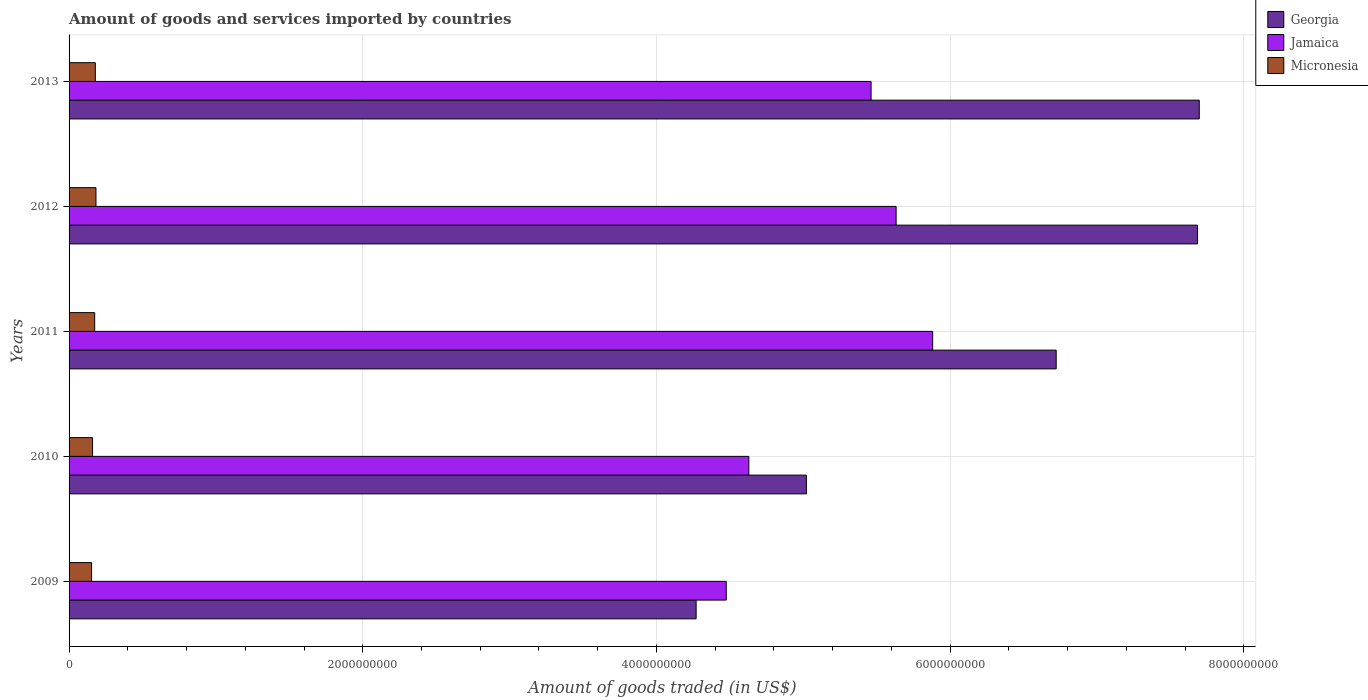How many different coloured bars are there?
Keep it short and to the point. 3. How many bars are there on the 3rd tick from the top?
Your answer should be compact. 3. What is the label of the 5th group of bars from the top?
Ensure brevity in your answer.  2009. What is the total amount of goods and services imported in Georgia in 2011?
Give a very brief answer. 6.72e+09. Across all years, what is the maximum total amount of goods and services imported in Jamaica?
Give a very brief answer. 5.88e+09. Across all years, what is the minimum total amount of goods and services imported in Micronesia?
Give a very brief answer. 1.53e+08. In which year was the total amount of goods and services imported in Georgia minimum?
Provide a short and direct response. 2009. What is the total total amount of goods and services imported in Georgia in the graph?
Your answer should be very brief. 3.14e+1. What is the difference between the total amount of goods and services imported in Micronesia in 2009 and that in 2012?
Offer a very short reply. -2.98e+07. What is the difference between the total amount of goods and services imported in Micronesia in 2013 and the total amount of goods and services imported in Jamaica in 2012?
Give a very brief answer. -5.45e+09. What is the average total amount of goods and services imported in Micronesia per year?
Ensure brevity in your answer.  1.70e+08. In the year 2012, what is the difference between the total amount of goods and services imported in Georgia and total amount of goods and services imported in Micronesia?
Provide a succinct answer. 7.50e+09. In how many years, is the total amount of goods and services imported in Jamaica greater than 7200000000 US$?
Your response must be concise. 0. What is the ratio of the total amount of goods and services imported in Georgia in 2010 to that in 2012?
Make the answer very short. 0.65. Is the difference between the total amount of goods and services imported in Georgia in 2010 and 2012 greater than the difference between the total amount of goods and services imported in Micronesia in 2010 and 2012?
Make the answer very short. No. What is the difference between the highest and the second highest total amount of goods and services imported in Micronesia?
Make the answer very short. 4.27e+06. What is the difference between the highest and the lowest total amount of goods and services imported in Micronesia?
Offer a very short reply. 2.98e+07. In how many years, is the total amount of goods and services imported in Micronesia greater than the average total amount of goods and services imported in Micronesia taken over all years?
Make the answer very short. 3. Is the sum of the total amount of goods and services imported in Micronesia in 2009 and 2011 greater than the maximum total amount of goods and services imported in Jamaica across all years?
Offer a terse response. No. What does the 1st bar from the top in 2009 represents?
Keep it short and to the point. Micronesia. What does the 2nd bar from the bottom in 2012 represents?
Offer a terse response. Jamaica. Is it the case that in every year, the sum of the total amount of goods and services imported in Georgia and total amount of goods and services imported in Jamaica is greater than the total amount of goods and services imported in Micronesia?
Offer a very short reply. Yes. Are all the bars in the graph horizontal?
Ensure brevity in your answer.  Yes. Does the graph contain grids?
Make the answer very short. Yes. How are the legend labels stacked?
Keep it short and to the point. Vertical. What is the title of the graph?
Give a very brief answer. Amount of goods and services imported by countries. Does "Tonga" appear as one of the legend labels in the graph?
Offer a terse response. No. What is the label or title of the X-axis?
Your answer should be very brief. Amount of goods traded (in US$). What is the label or title of the Y-axis?
Provide a short and direct response. Years. What is the Amount of goods traded (in US$) of Georgia in 2009?
Your response must be concise. 4.27e+09. What is the Amount of goods traded (in US$) in Jamaica in 2009?
Your response must be concise. 4.48e+09. What is the Amount of goods traded (in US$) in Micronesia in 2009?
Ensure brevity in your answer.  1.53e+08. What is the Amount of goods traded (in US$) of Georgia in 2010?
Ensure brevity in your answer.  5.02e+09. What is the Amount of goods traded (in US$) of Jamaica in 2010?
Your answer should be compact. 4.63e+09. What is the Amount of goods traded (in US$) of Micronesia in 2010?
Your answer should be very brief. 1.60e+08. What is the Amount of goods traded (in US$) of Georgia in 2011?
Offer a terse response. 6.72e+09. What is the Amount of goods traded (in US$) of Jamaica in 2011?
Provide a short and direct response. 5.88e+09. What is the Amount of goods traded (in US$) of Micronesia in 2011?
Make the answer very short. 1.74e+08. What is the Amount of goods traded (in US$) in Georgia in 2012?
Keep it short and to the point. 7.69e+09. What is the Amount of goods traded (in US$) in Jamaica in 2012?
Your answer should be very brief. 5.63e+09. What is the Amount of goods traded (in US$) in Micronesia in 2012?
Your answer should be very brief. 1.83e+08. What is the Amount of goods traded (in US$) of Georgia in 2013?
Provide a succinct answer. 7.70e+09. What is the Amount of goods traded (in US$) of Jamaica in 2013?
Your response must be concise. 5.46e+09. What is the Amount of goods traded (in US$) of Micronesia in 2013?
Your answer should be compact. 1.79e+08. Across all years, what is the maximum Amount of goods traded (in US$) of Georgia?
Ensure brevity in your answer.  7.70e+09. Across all years, what is the maximum Amount of goods traded (in US$) of Jamaica?
Provide a succinct answer. 5.88e+09. Across all years, what is the maximum Amount of goods traded (in US$) of Micronesia?
Your response must be concise. 1.83e+08. Across all years, what is the minimum Amount of goods traded (in US$) in Georgia?
Keep it short and to the point. 4.27e+09. Across all years, what is the minimum Amount of goods traded (in US$) of Jamaica?
Make the answer very short. 4.48e+09. Across all years, what is the minimum Amount of goods traded (in US$) in Micronesia?
Your answer should be compact. 1.53e+08. What is the total Amount of goods traded (in US$) in Georgia in the graph?
Provide a succinct answer. 3.14e+1. What is the total Amount of goods traded (in US$) in Jamaica in the graph?
Provide a short and direct response. 2.61e+1. What is the total Amount of goods traded (in US$) in Micronesia in the graph?
Your answer should be compact. 8.50e+08. What is the difference between the Amount of goods traded (in US$) in Georgia in 2009 and that in 2010?
Your response must be concise. -7.51e+08. What is the difference between the Amount of goods traded (in US$) in Jamaica in 2009 and that in 2010?
Your answer should be very brief. -1.54e+08. What is the difference between the Amount of goods traded (in US$) in Micronesia in 2009 and that in 2010?
Provide a short and direct response. -6.59e+06. What is the difference between the Amount of goods traded (in US$) in Georgia in 2009 and that in 2011?
Keep it short and to the point. -2.45e+09. What is the difference between the Amount of goods traded (in US$) of Jamaica in 2009 and that in 2011?
Offer a very short reply. -1.41e+09. What is the difference between the Amount of goods traded (in US$) of Micronesia in 2009 and that in 2011?
Give a very brief answer. -2.10e+07. What is the difference between the Amount of goods traded (in US$) in Georgia in 2009 and that in 2012?
Your answer should be very brief. -3.41e+09. What is the difference between the Amount of goods traded (in US$) in Jamaica in 2009 and that in 2012?
Offer a terse response. -1.16e+09. What is the difference between the Amount of goods traded (in US$) of Micronesia in 2009 and that in 2012?
Your response must be concise. -2.98e+07. What is the difference between the Amount of goods traded (in US$) of Georgia in 2009 and that in 2013?
Your answer should be very brief. -3.43e+09. What is the difference between the Amount of goods traded (in US$) in Jamaica in 2009 and that in 2013?
Offer a very short reply. -9.86e+08. What is the difference between the Amount of goods traded (in US$) in Micronesia in 2009 and that in 2013?
Make the answer very short. -2.55e+07. What is the difference between the Amount of goods traded (in US$) of Georgia in 2010 and that in 2011?
Offer a terse response. -1.70e+09. What is the difference between the Amount of goods traded (in US$) of Jamaica in 2010 and that in 2011?
Offer a very short reply. -1.25e+09. What is the difference between the Amount of goods traded (in US$) of Micronesia in 2010 and that in 2011?
Your answer should be compact. -1.44e+07. What is the difference between the Amount of goods traded (in US$) in Georgia in 2010 and that in 2012?
Ensure brevity in your answer.  -2.66e+09. What is the difference between the Amount of goods traded (in US$) of Jamaica in 2010 and that in 2012?
Keep it short and to the point. -1.00e+09. What is the difference between the Amount of goods traded (in US$) of Micronesia in 2010 and that in 2012?
Offer a terse response. -2.32e+07. What is the difference between the Amount of goods traded (in US$) in Georgia in 2010 and that in 2013?
Give a very brief answer. -2.68e+09. What is the difference between the Amount of goods traded (in US$) in Jamaica in 2010 and that in 2013?
Your answer should be very brief. -8.33e+08. What is the difference between the Amount of goods traded (in US$) of Micronesia in 2010 and that in 2013?
Offer a terse response. -1.89e+07. What is the difference between the Amount of goods traded (in US$) in Georgia in 2011 and that in 2012?
Your answer should be compact. -9.63e+08. What is the difference between the Amount of goods traded (in US$) of Jamaica in 2011 and that in 2012?
Offer a very short reply. 2.49e+08. What is the difference between the Amount of goods traded (in US$) in Micronesia in 2011 and that in 2012?
Offer a very short reply. -8.79e+06. What is the difference between the Amount of goods traded (in US$) of Georgia in 2011 and that in 2013?
Your response must be concise. -9.74e+08. What is the difference between the Amount of goods traded (in US$) of Jamaica in 2011 and that in 2013?
Your response must be concise. 4.19e+08. What is the difference between the Amount of goods traded (in US$) in Micronesia in 2011 and that in 2013?
Offer a terse response. -4.51e+06. What is the difference between the Amount of goods traded (in US$) in Georgia in 2012 and that in 2013?
Offer a terse response. -1.18e+07. What is the difference between the Amount of goods traded (in US$) in Jamaica in 2012 and that in 2013?
Give a very brief answer. 1.70e+08. What is the difference between the Amount of goods traded (in US$) in Micronesia in 2012 and that in 2013?
Offer a terse response. 4.27e+06. What is the difference between the Amount of goods traded (in US$) in Georgia in 2009 and the Amount of goods traded (in US$) in Jamaica in 2010?
Your response must be concise. -3.59e+08. What is the difference between the Amount of goods traded (in US$) of Georgia in 2009 and the Amount of goods traded (in US$) of Micronesia in 2010?
Ensure brevity in your answer.  4.11e+09. What is the difference between the Amount of goods traded (in US$) of Jamaica in 2009 and the Amount of goods traded (in US$) of Micronesia in 2010?
Provide a short and direct response. 4.32e+09. What is the difference between the Amount of goods traded (in US$) of Georgia in 2009 and the Amount of goods traded (in US$) of Jamaica in 2011?
Your answer should be very brief. -1.61e+09. What is the difference between the Amount of goods traded (in US$) of Georgia in 2009 and the Amount of goods traded (in US$) of Micronesia in 2011?
Your answer should be very brief. 4.10e+09. What is the difference between the Amount of goods traded (in US$) of Jamaica in 2009 and the Amount of goods traded (in US$) of Micronesia in 2011?
Offer a terse response. 4.30e+09. What is the difference between the Amount of goods traded (in US$) in Georgia in 2009 and the Amount of goods traded (in US$) in Jamaica in 2012?
Make the answer very short. -1.36e+09. What is the difference between the Amount of goods traded (in US$) of Georgia in 2009 and the Amount of goods traded (in US$) of Micronesia in 2012?
Provide a short and direct response. 4.09e+09. What is the difference between the Amount of goods traded (in US$) in Jamaica in 2009 and the Amount of goods traded (in US$) in Micronesia in 2012?
Provide a succinct answer. 4.29e+09. What is the difference between the Amount of goods traded (in US$) in Georgia in 2009 and the Amount of goods traded (in US$) in Jamaica in 2013?
Provide a short and direct response. -1.19e+09. What is the difference between the Amount of goods traded (in US$) in Georgia in 2009 and the Amount of goods traded (in US$) in Micronesia in 2013?
Make the answer very short. 4.09e+09. What is the difference between the Amount of goods traded (in US$) of Jamaica in 2009 and the Amount of goods traded (in US$) of Micronesia in 2013?
Your answer should be very brief. 4.30e+09. What is the difference between the Amount of goods traded (in US$) in Georgia in 2010 and the Amount of goods traded (in US$) in Jamaica in 2011?
Offer a terse response. -8.60e+08. What is the difference between the Amount of goods traded (in US$) in Georgia in 2010 and the Amount of goods traded (in US$) in Micronesia in 2011?
Ensure brevity in your answer.  4.85e+09. What is the difference between the Amount of goods traded (in US$) in Jamaica in 2010 and the Amount of goods traded (in US$) in Micronesia in 2011?
Ensure brevity in your answer.  4.45e+09. What is the difference between the Amount of goods traded (in US$) in Georgia in 2010 and the Amount of goods traded (in US$) in Jamaica in 2012?
Provide a short and direct response. -6.11e+08. What is the difference between the Amount of goods traded (in US$) of Georgia in 2010 and the Amount of goods traded (in US$) of Micronesia in 2012?
Your answer should be very brief. 4.84e+09. What is the difference between the Amount of goods traded (in US$) in Jamaica in 2010 and the Amount of goods traded (in US$) in Micronesia in 2012?
Make the answer very short. 4.45e+09. What is the difference between the Amount of goods traded (in US$) in Georgia in 2010 and the Amount of goods traded (in US$) in Jamaica in 2013?
Your answer should be compact. -4.41e+08. What is the difference between the Amount of goods traded (in US$) in Georgia in 2010 and the Amount of goods traded (in US$) in Micronesia in 2013?
Your answer should be compact. 4.84e+09. What is the difference between the Amount of goods traded (in US$) in Jamaica in 2010 and the Amount of goods traded (in US$) in Micronesia in 2013?
Make the answer very short. 4.45e+09. What is the difference between the Amount of goods traded (in US$) in Georgia in 2011 and the Amount of goods traded (in US$) in Jamaica in 2012?
Offer a very short reply. 1.09e+09. What is the difference between the Amount of goods traded (in US$) of Georgia in 2011 and the Amount of goods traded (in US$) of Micronesia in 2012?
Your answer should be compact. 6.54e+09. What is the difference between the Amount of goods traded (in US$) of Jamaica in 2011 and the Amount of goods traded (in US$) of Micronesia in 2012?
Your response must be concise. 5.70e+09. What is the difference between the Amount of goods traded (in US$) of Georgia in 2011 and the Amount of goods traded (in US$) of Jamaica in 2013?
Ensure brevity in your answer.  1.26e+09. What is the difference between the Amount of goods traded (in US$) of Georgia in 2011 and the Amount of goods traded (in US$) of Micronesia in 2013?
Your answer should be compact. 6.54e+09. What is the difference between the Amount of goods traded (in US$) of Jamaica in 2011 and the Amount of goods traded (in US$) of Micronesia in 2013?
Your response must be concise. 5.70e+09. What is the difference between the Amount of goods traded (in US$) in Georgia in 2012 and the Amount of goods traded (in US$) in Jamaica in 2013?
Make the answer very short. 2.22e+09. What is the difference between the Amount of goods traded (in US$) of Georgia in 2012 and the Amount of goods traded (in US$) of Micronesia in 2013?
Your answer should be compact. 7.51e+09. What is the difference between the Amount of goods traded (in US$) in Jamaica in 2012 and the Amount of goods traded (in US$) in Micronesia in 2013?
Provide a succinct answer. 5.45e+09. What is the average Amount of goods traded (in US$) of Georgia per year?
Ensure brevity in your answer.  6.28e+09. What is the average Amount of goods traded (in US$) in Jamaica per year?
Provide a succinct answer. 5.22e+09. What is the average Amount of goods traded (in US$) in Micronesia per year?
Keep it short and to the point. 1.70e+08. In the year 2009, what is the difference between the Amount of goods traded (in US$) of Georgia and Amount of goods traded (in US$) of Jamaica?
Your response must be concise. -2.05e+08. In the year 2009, what is the difference between the Amount of goods traded (in US$) of Georgia and Amount of goods traded (in US$) of Micronesia?
Your answer should be very brief. 4.12e+09. In the year 2009, what is the difference between the Amount of goods traded (in US$) in Jamaica and Amount of goods traded (in US$) in Micronesia?
Give a very brief answer. 4.32e+09. In the year 2010, what is the difference between the Amount of goods traded (in US$) in Georgia and Amount of goods traded (in US$) in Jamaica?
Provide a short and direct response. 3.92e+08. In the year 2010, what is the difference between the Amount of goods traded (in US$) in Georgia and Amount of goods traded (in US$) in Micronesia?
Provide a succinct answer. 4.86e+09. In the year 2010, what is the difference between the Amount of goods traded (in US$) of Jamaica and Amount of goods traded (in US$) of Micronesia?
Provide a short and direct response. 4.47e+09. In the year 2011, what is the difference between the Amount of goods traded (in US$) of Georgia and Amount of goods traded (in US$) of Jamaica?
Offer a terse response. 8.41e+08. In the year 2011, what is the difference between the Amount of goods traded (in US$) in Georgia and Amount of goods traded (in US$) in Micronesia?
Your answer should be very brief. 6.55e+09. In the year 2011, what is the difference between the Amount of goods traded (in US$) in Jamaica and Amount of goods traded (in US$) in Micronesia?
Keep it short and to the point. 5.71e+09. In the year 2012, what is the difference between the Amount of goods traded (in US$) in Georgia and Amount of goods traded (in US$) in Jamaica?
Offer a very short reply. 2.05e+09. In the year 2012, what is the difference between the Amount of goods traded (in US$) in Georgia and Amount of goods traded (in US$) in Micronesia?
Provide a succinct answer. 7.50e+09. In the year 2012, what is the difference between the Amount of goods traded (in US$) in Jamaica and Amount of goods traded (in US$) in Micronesia?
Ensure brevity in your answer.  5.45e+09. In the year 2013, what is the difference between the Amount of goods traded (in US$) in Georgia and Amount of goods traded (in US$) in Jamaica?
Offer a very short reply. 2.24e+09. In the year 2013, what is the difference between the Amount of goods traded (in US$) of Georgia and Amount of goods traded (in US$) of Micronesia?
Provide a short and direct response. 7.52e+09. In the year 2013, what is the difference between the Amount of goods traded (in US$) of Jamaica and Amount of goods traded (in US$) of Micronesia?
Provide a succinct answer. 5.28e+09. What is the ratio of the Amount of goods traded (in US$) of Georgia in 2009 to that in 2010?
Make the answer very short. 0.85. What is the ratio of the Amount of goods traded (in US$) of Jamaica in 2009 to that in 2010?
Provide a succinct answer. 0.97. What is the ratio of the Amount of goods traded (in US$) in Micronesia in 2009 to that in 2010?
Give a very brief answer. 0.96. What is the ratio of the Amount of goods traded (in US$) in Georgia in 2009 to that in 2011?
Provide a succinct answer. 0.64. What is the ratio of the Amount of goods traded (in US$) in Jamaica in 2009 to that in 2011?
Offer a very short reply. 0.76. What is the ratio of the Amount of goods traded (in US$) in Micronesia in 2009 to that in 2011?
Make the answer very short. 0.88. What is the ratio of the Amount of goods traded (in US$) in Georgia in 2009 to that in 2012?
Give a very brief answer. 0.56. What is the ratio of the Amount of goods traded (in US$) in Jamaica in 2009 to that in 2012?
Keep it short and to the point. 0.79. What is the ratio of the Amount of goods traded (in US$) in Micronesia in 2009 to that in 2012?
Offer a terse response. 0.84. What is the ratio of the Amount of goods traded (in US$) of Georgia in 2009 to that in 2013?
Provide a short and direct response. 0.55. What is the ratio of the Amount of goods traded (in US$) of Jamaica in 2009 to that in 2013?
Your answer should be very brief. 0.82. What is the ratio of the Amount of goods traded (in US$) in Micronesia in 2009 to that in 2013?
Keep it short and to the point. 0.86. What is the ratio of the Amount of goods traded (in US$) of Georgia in 2010 to that in 2011?
Your response must be concise. 0.75. What is the ratio of the Amount of goods traded (in US$) of Jamaica in 2010 to that in 2011?
Provide a succinct answer. 0.79. What is the ratio of the Amount of goods traded (in US$) in Micronesia in 2010 to that in 2011?
Provide a succinct answer. 0.92. What is the ratio of the Amount of goods traded (in US$) of Georgia in 2010 to that in 2012?
Keep it short and to the point. 0.65. What is the ratio of the Amount of goods traded (in US$) in Jamaica in 2010 to that in 2012?
Your answer should be compact. 0.82. What is the ratio of the Amount of goods traded (in US$) in Micronesia in 2010 to that in 2012?
Keep it short and to the point. 0.87. What is the ratio of the Amount of goods traded (in US$) of Georgia in 2010 to that in 2013?
Your answer should be very brief. 0.65. What is the ratio of the Amount of goods traded (in US$) in Jamaica in 2010 to that in 2013?
Your answer should be compact. 0.85. What is the ratio of the Amount of goods traded (in US$) in Micronesia in 2010 to that in 2013?
Provide a short and direct response. 0.89. What is the ratio of the Amount of goods traded (in US$) in Georgia in 2011 to that in 2012?
Offer a terse response. 0.87. What is the ratio of the Amount of goods traded (in US$) in Jamaica in 2011 to that in 2012?
Make the answer very short. 1.04. What is the ratio of the Amount of goods traded (in US$) of Georgia in 2011 to that in 2013?
Ensure brevity in your answer.  0.87. What is the ratio of the Amount of goods traded (in US$) of Jamaica in 2011 to that in 2013?
Give a very brief answer. 1.08. What is the ratio of the Amount of goods traded (in US$) of Micronesia in 2011 to that in 2013?
Give a very brief answer. 0.97. What is the ratio of the Amount of goods traded (in US$) in Jamaica in 2012 to that in 2013?
Offer a terse response. 1.03. What is the ratio of the Amount of goods traded (in US$) of Micronesia in 2012 to that in 2013?
Offer a very short reply. 1.02. What is the difference between the highest and the second highest Amount of goods traded (in US$) in Georgia?
Offer a terse response. 1.18e+07. What is the difference between the highest and the second highest Amount of goods traded (in US$) of Jamaica?
Give a very brief answer. 2.49e+08. What is the difference between the highest and the second highest Amount of goods traded (in US$) in Micronesia?
Your answer should be compact. 4.27e+06. What is the difference between the highest and the lowest Amount of goods traded (in US$) in Georgia?
Offer a terse response. 3.43e+09. What is the difference between the highest and the lowest Amount of goods traded (in US$) in Jamaica?
Keep it short and to the point. 1.41e+09. What is the difference between the highest and the lowest Amount of goods traded (in US$) of Micronesia?
Offer a terse response. 2.98e+07. 